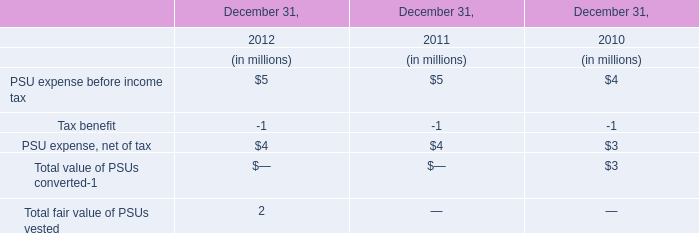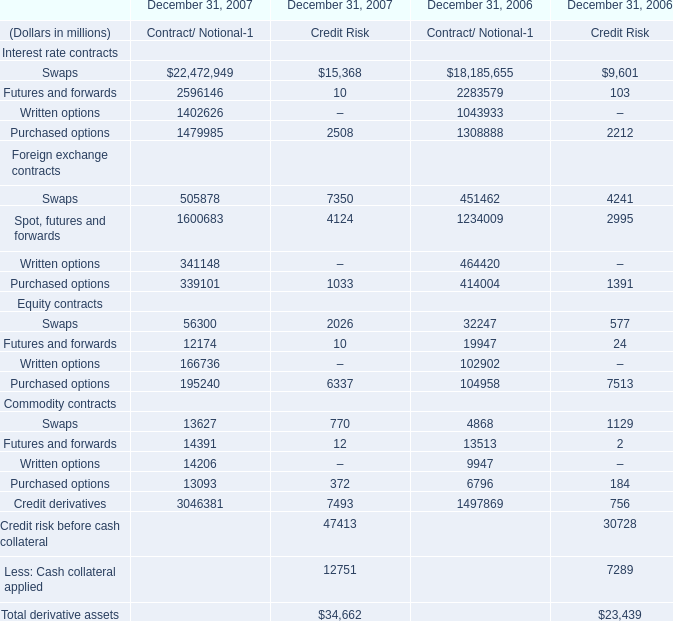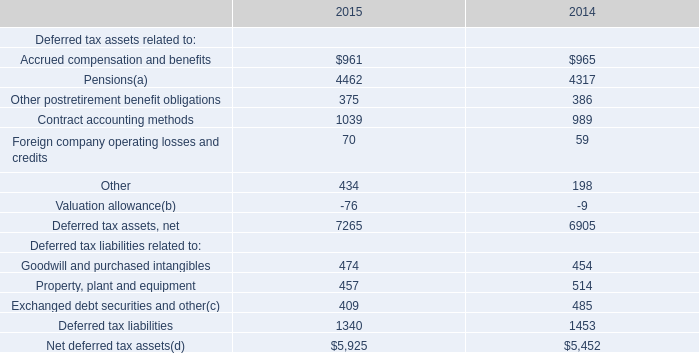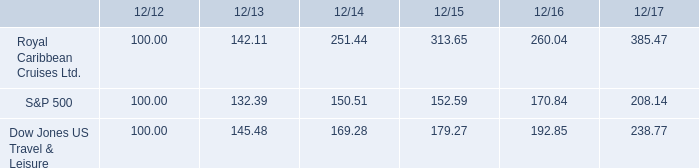What's the difference of Total derivative assets between 2006 and 2007? (in million) 
Computations: (34662 - 23439)
Answer: 11223.0. 